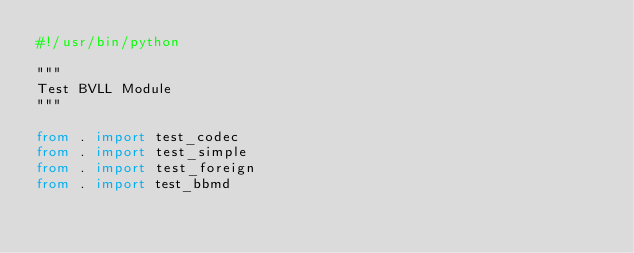Convert code to text. <code><loc_0><loc_0><loc_500><loc_500><_Python_>#!/usr/bin/python

"""
Test BVLL Module
"""

from . import test_codec
from . import test_simple
from . import test_foreign
from . import test_bbmd

</code> 